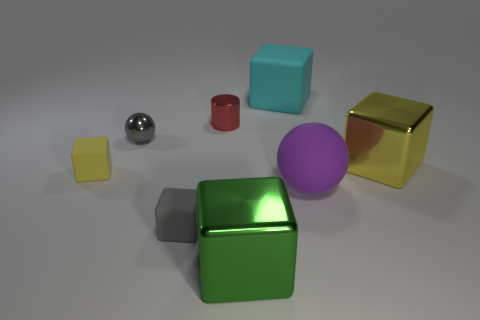Can you describe the light source and how it affects the appearance of the objects? The scene is lit from above, creating soft shadows directly underneath the objects. The light source appears diffuse, likely a softbox or similar equipment, giving the objects a gentle illumination with subtle highlights that add dimension without causing harsh glares. How does the surface the objects are resting on contribute to the overall aesthetic? The surface is gently textured and has a neutral tone, which provides a non-distracting backdrop that complements the various colors and finishes of the objects. Its matte finish reduces reflections, allowing each object's material to stand out distinctly. 